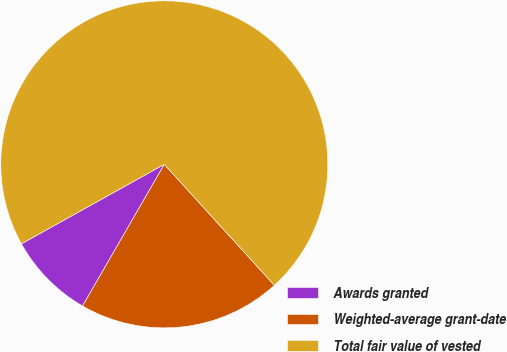Convert chart to OTSL. <chart><loc_0><loc_0><loc_500><loc_500><pie_chart><fcel>Awards granted<fcel>Weighted-average grant-date<fcel>Total fair value of vested<nl><fcel>8.59%<fcel>20.08%<fcel>71.33%<nl></chart> 